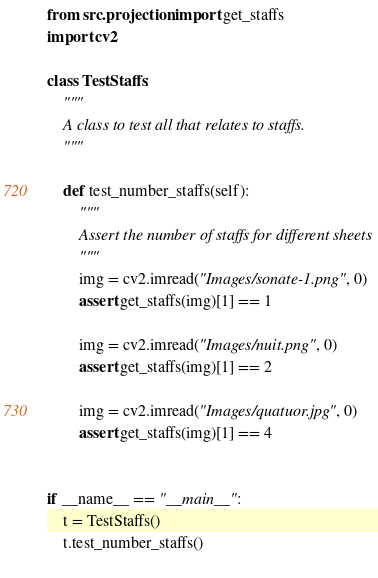<code> <loc_0><loc_0><loc_500><loc_500><_Python_>from src.projection import get_staffs
import cv2

class TestStaffs:
    """
    A class to test all that relates to staffs. 
    """

    def test_number_staffs(self):
        """
        Assert the number of staffs for different sheets
        """
        img = cv2.imread("Images/sonate-1.png", 0)
        assert get_staffs(img)[1] == 1

        img = cv2.imread("Images/nuit.png", 0)
        assert get_staffs(img)[1] == 2

        img = cv2.imread("Images/quatuor.jpg", 0)
        assert get_staffs(img)[1] == 4


if __name__ == "__main__":
    t = TestStaffs()
    t.test_number_staffs()
        </code> 